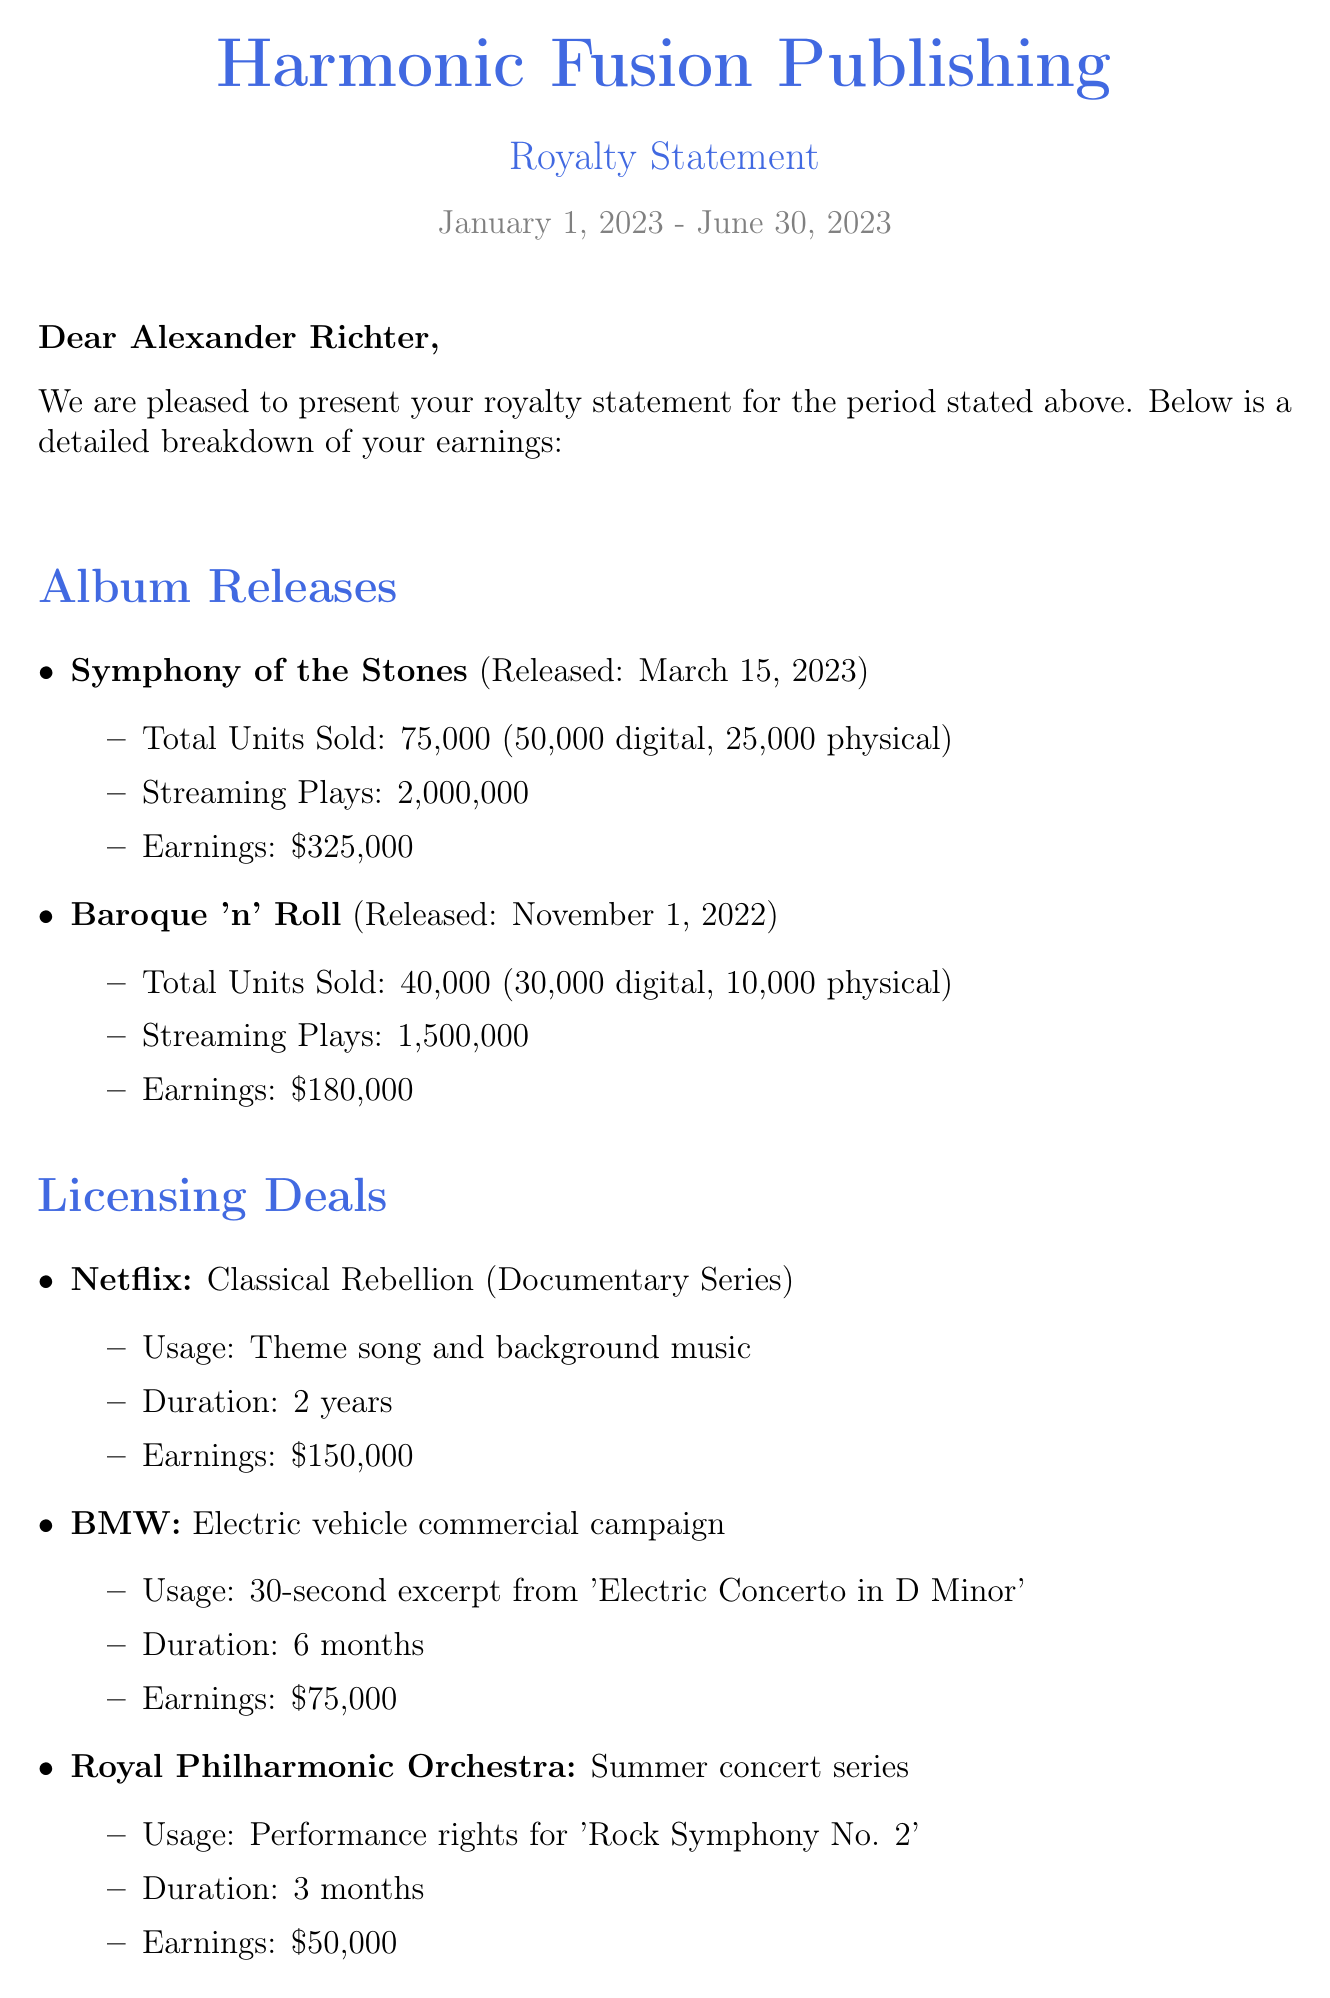What is the total earnings for the period? The total earnings is provided in the financial summary section of the document, which states it is $780,000.
Answer: $780,000 What is the release date of "Symphony of the Stones"? The release date can be found under the album releases section, specifically stated as March 15, 2023.
Answer: March 15, 2023 How many physical copies of "Baroque 'n' Roll" were sold? The number of physical copies sold is listed in the album releases section, which indicates 10,000 physical sales for "Baroque 'n' Roll".
Answer: 10,000 What is the earnings from the Netflix licensing deal? The earnings from the Netflix licensing deal is explicitly stated in the licensing deals section as $150,000.
Answer: $150,000 What is the net royalty payment? The net royalty payment is summarized in the financial summary section and is specified as $70,200.
Answer: $70,200 Which album has become the highest-grossing to date? The document notes in the additional notes section that "Symphony of the Stones" has become the highest-grossing album to date.
Answer: Symphony of the Stones What percentage is the royalty rate mentioned in the document? The royalty rate is indicated in the financial summary section as 15%.
Answer: 15% How many months is the licensing deal with the Royal Philharmonic Orchestra for? The duration of the licensing deal for the Royal Philharmonic Orchestra is detailed in the licensing deals section, stating it is for 3 months.
Answer: 3 months What is the payment method mentioned for the royalty payment? The payment method is provided in the document, specifying direct deposit to a Barclays Bank account ending in 4389.
Answer: Direct deposit to Barclays Bank account ending in 4389 